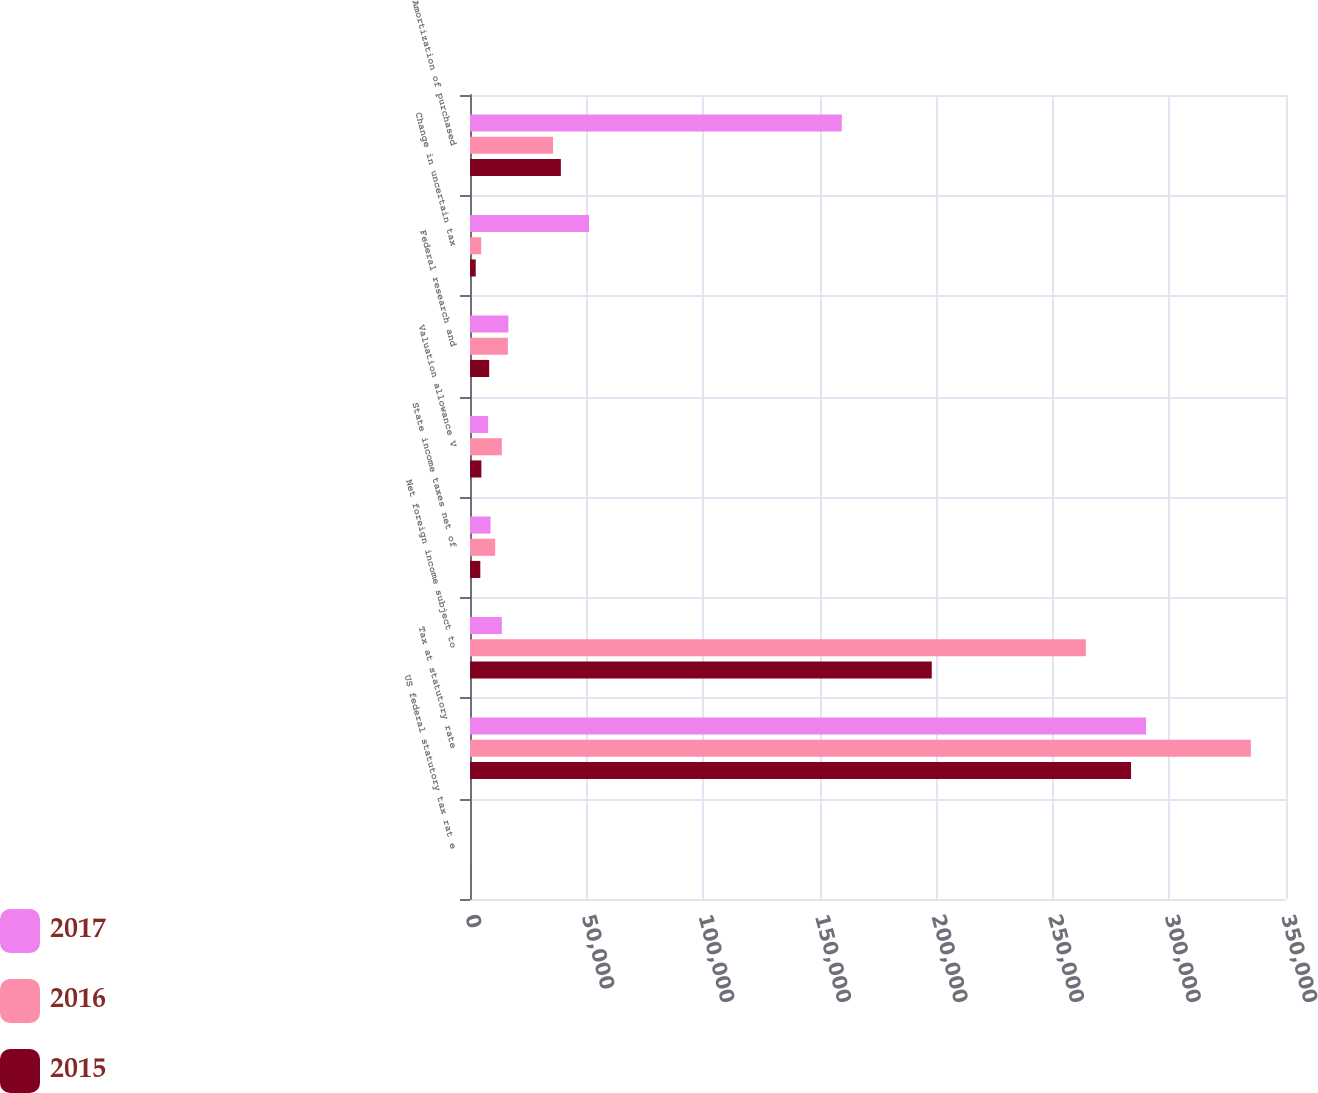Convert chart. <chart><loc_0><loc_0><loc_500><loc_500><stacked_bar_chart><ecel><fcel>US federal statutory tax rat e<fcel>Tax at statutory rate<fcel>Net foreign income subject to<fcel>State income taxes net of<fcel>Valuation allowance V<fcel>Federal research and<fcel>Change in uncertain tax<fcel>Amortization of purchased<nl><fcel>2017<fcel>35<fcel>289970<fcel>13658<fcel>8801<fcel>7778<fcel>16475<fcel>51088<fcel>159466<nl><fcel>2016<fcel>35<fcel>334922<fcel>264157<fcel>10821<fcel>13658<fcel>16237<fcel>4797<fcel>35641<nl><fcel>2015<fcel>35<fcel>283540<fcel>198061<fcel>4425<fcel>4875<fcel>8232<fcel>2449<fcel>38973<nl></chart> 